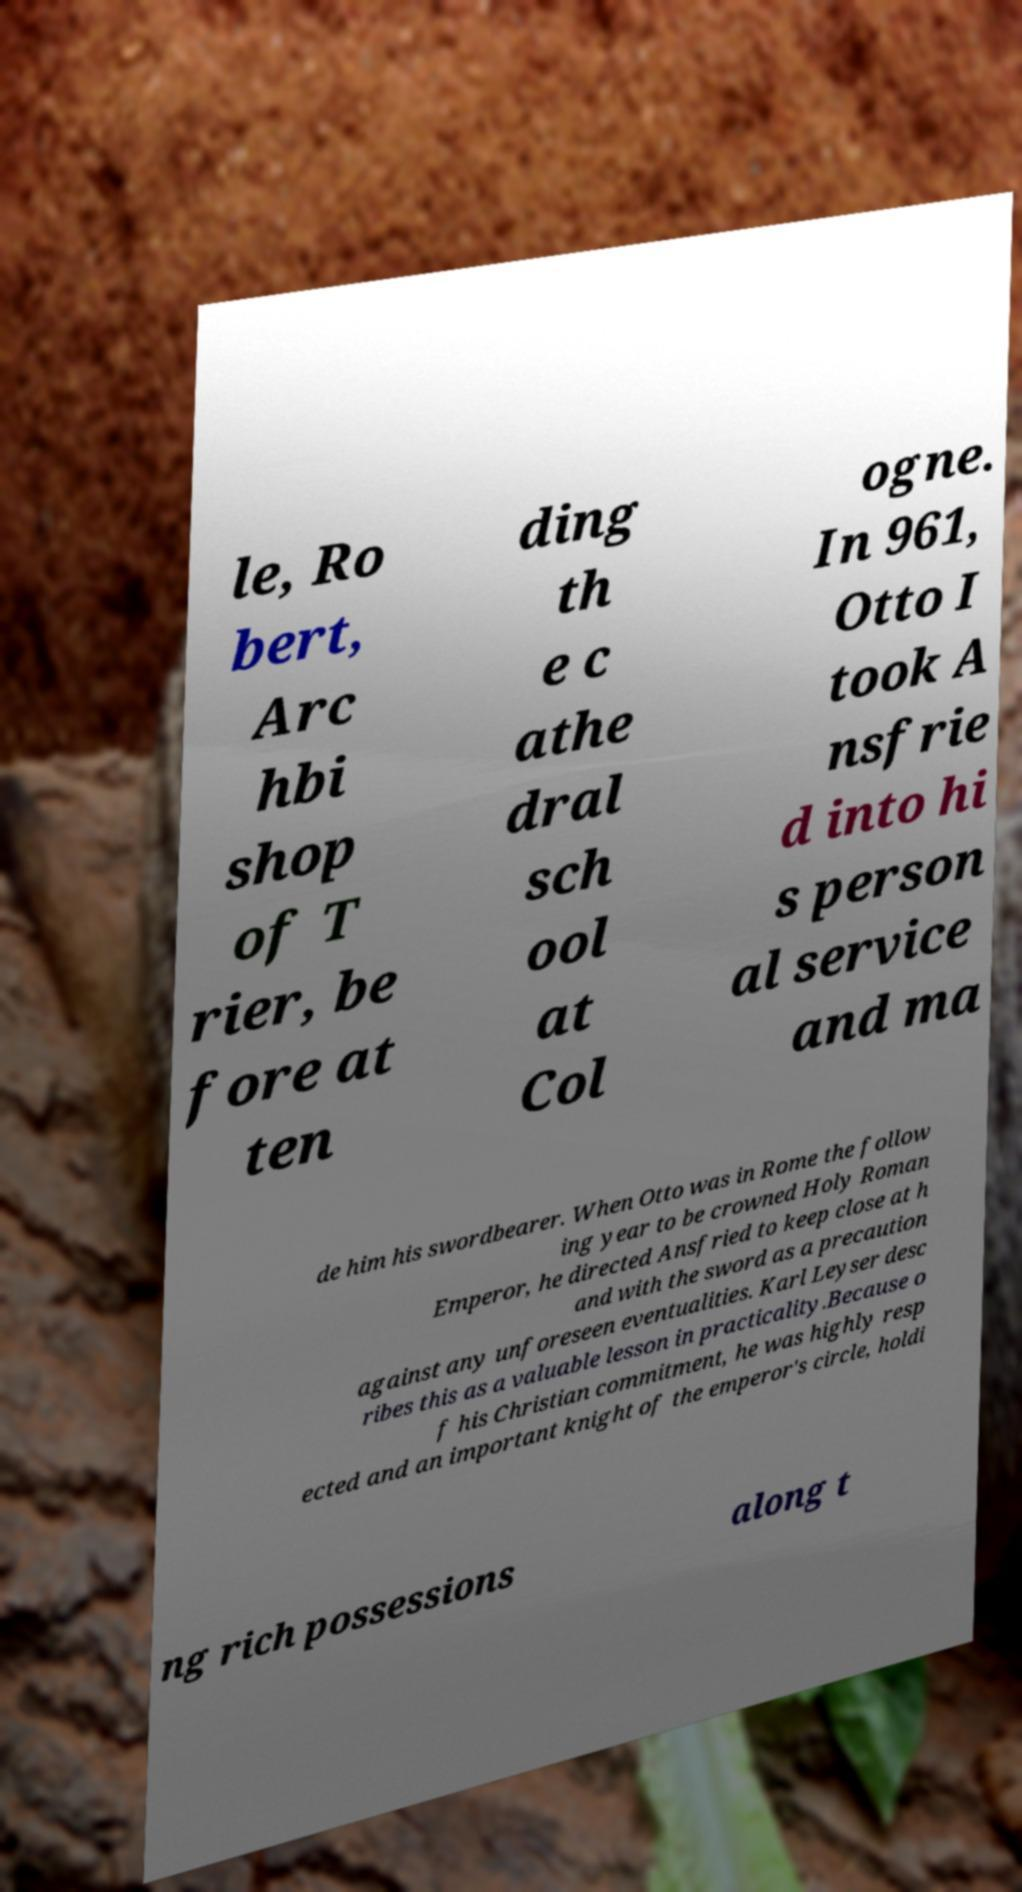What messages or text are displayed in this image? I need them in a readable, typed format. le, Ro bert, Arc hbi shop of T rier, be fore at ten ding th e c athe dral sch ool at Col ogne. In 961, Otto I took A nsfrie d into hi s person al service and ma de him his swordbearer. When Otto was in Rome the follow ing year to be crowned Holy Roman Emperor, he directed Ansfried to keep close at h and with the sword as a precaution against any unforeseen eventualities. Karl Leyser desc ribes this as a valuable lesson in practicality.Because o f his Christian commitment, he was highly resp ected and an important knight of the emperor's circle, holdi ng rich possessions along t 